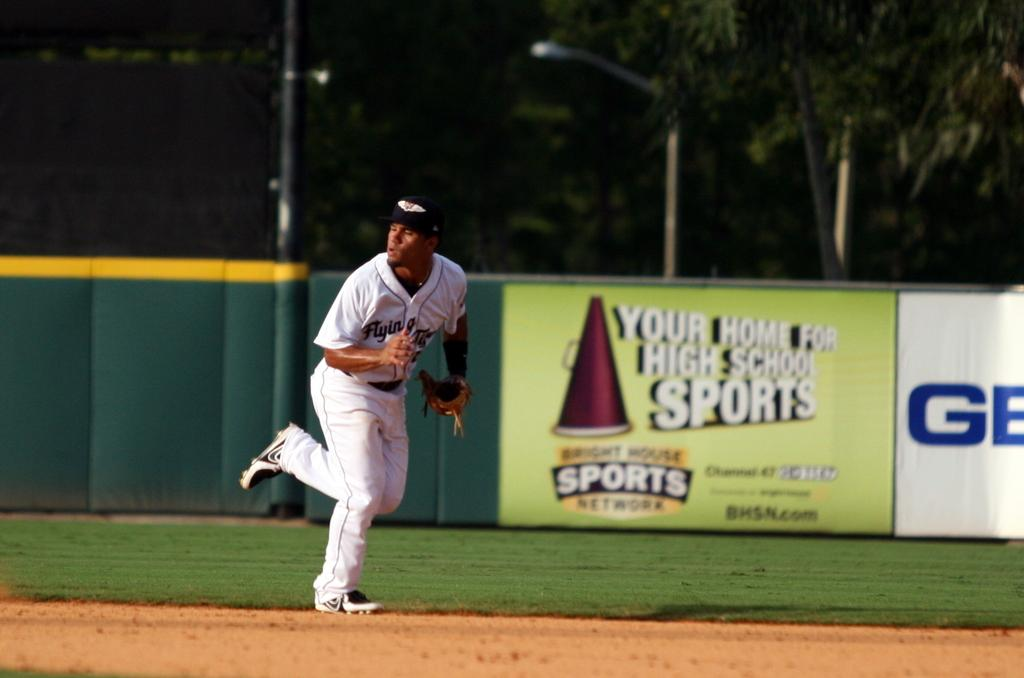<image>
Describe the image concisely. A baseball player fields a ball in front of a Geico banner. 